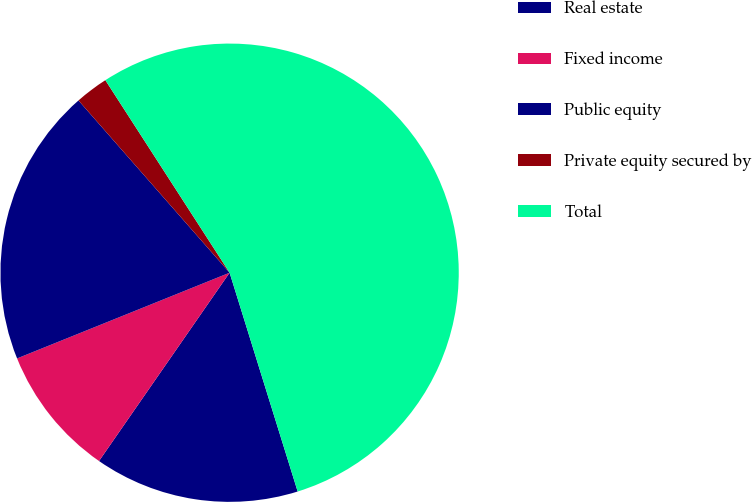<chart> <loc_0><loc_0><loc_500><loc_500><pie_chart><fcel>Real estate<fcel>Fixed income<fcel>Public equity<fcel>Private equity secured by<fcel>Total<nl><fcel>14.45%<fcel>9.25%<fcel>19.64%<fcel>2.34%<fcel>54.32%<nl></chart> 